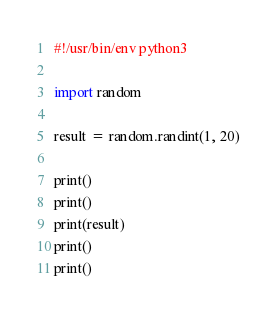Convert code to text. <code><loc_0><loc_0><loc_500><loc_500><_Python_>#!/usr/bin/env python3

import random

result = random.randint(1, 20)

print()
print()
print(result)
print()
print()
</code> 